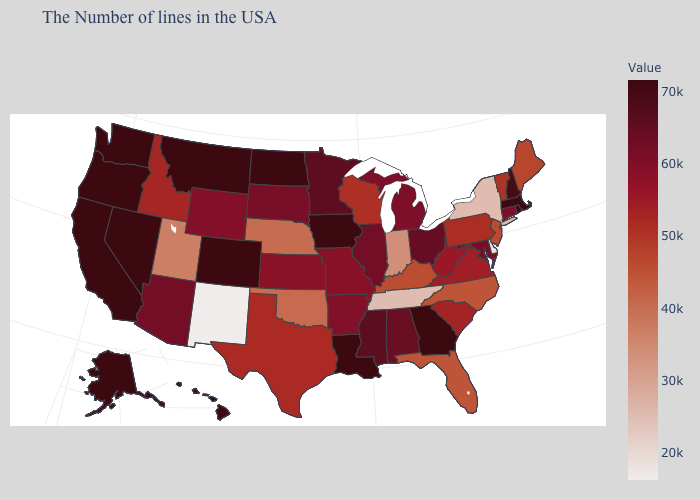Among the states that border Virginia , which have the lowest value?
Quick response, please. Tennessee. Does Oregon have the highest value in the West?
Give a very brief answer. Yes. Among the states that border New Hampshire , does Vermont have the lowest value?
Write a very short answer. No. 